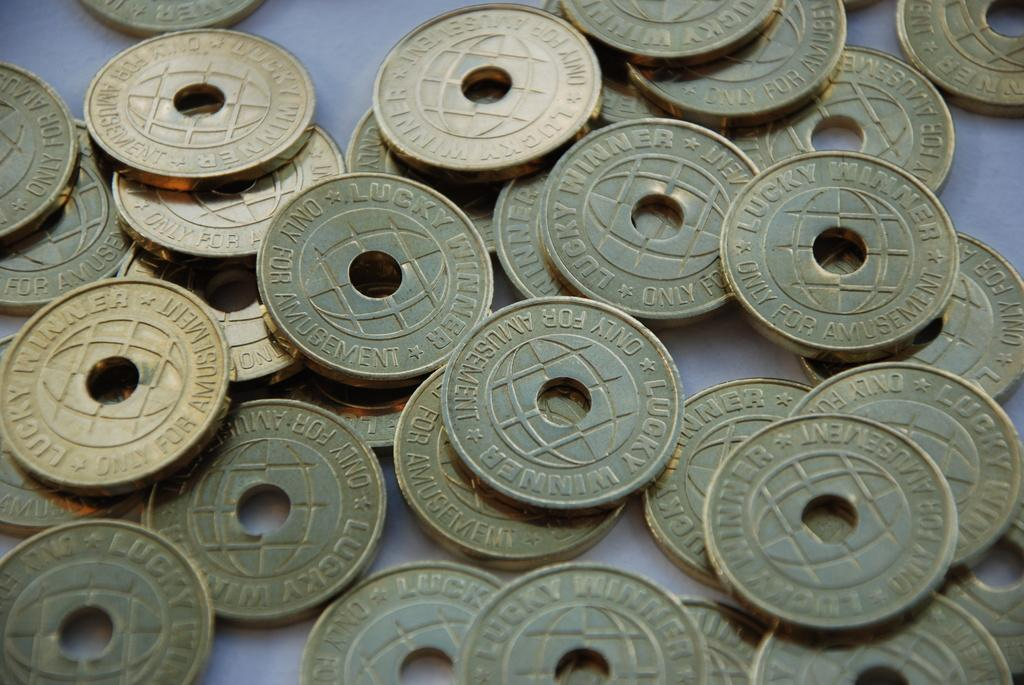<image>
Render a clear and concise summary of the photo. Many coins on a table and says "AMUSEMENT" on one side. 